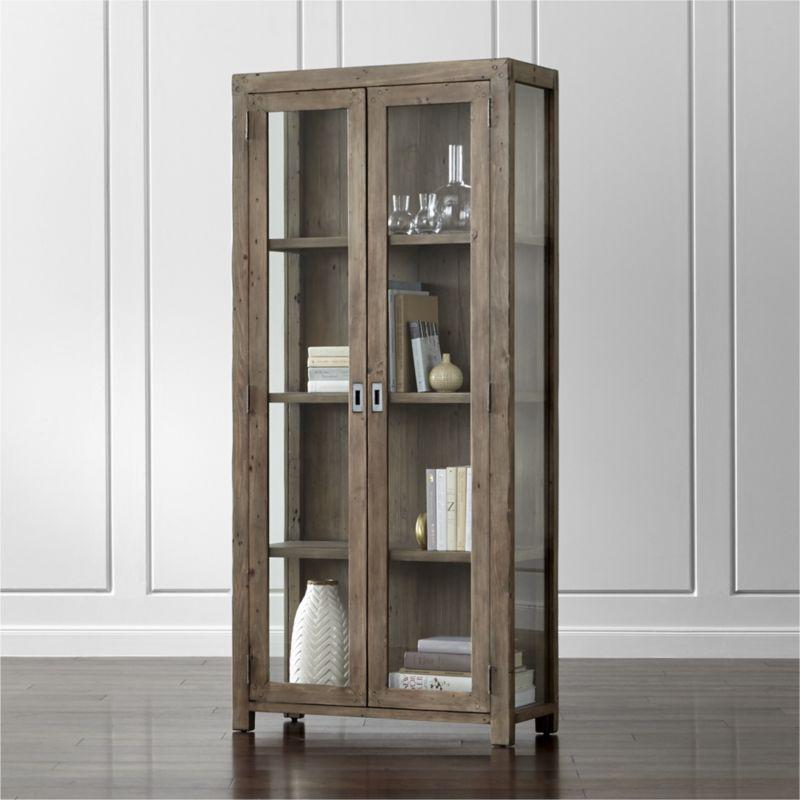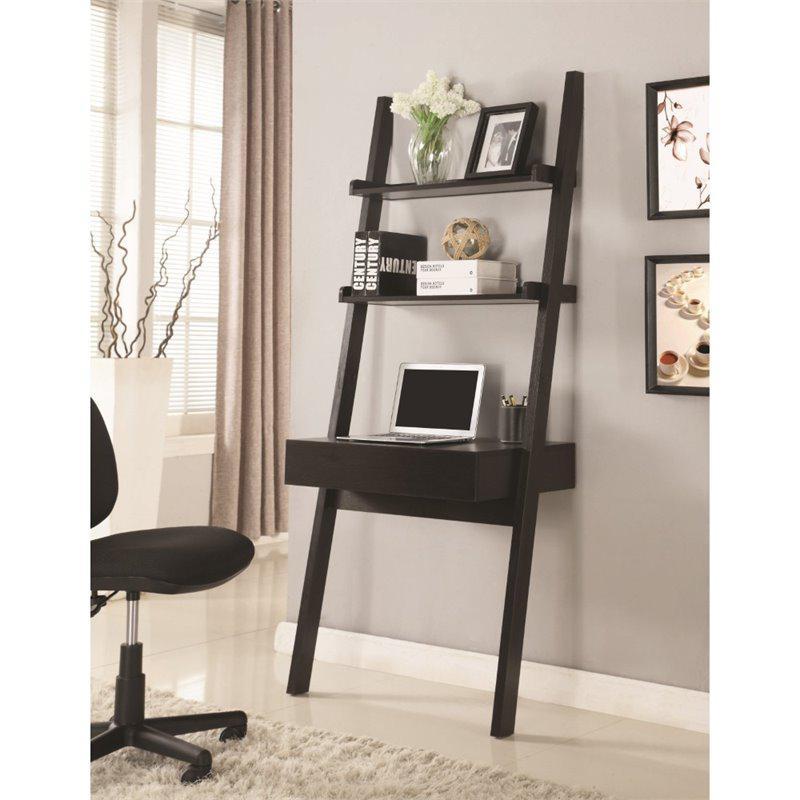The first image is the image on the left, the second image is the image on the right. Given the left and right images, does the statement "One shelf has 3 columns, while the other one has only one." hold true? Answer yes or no. No. 